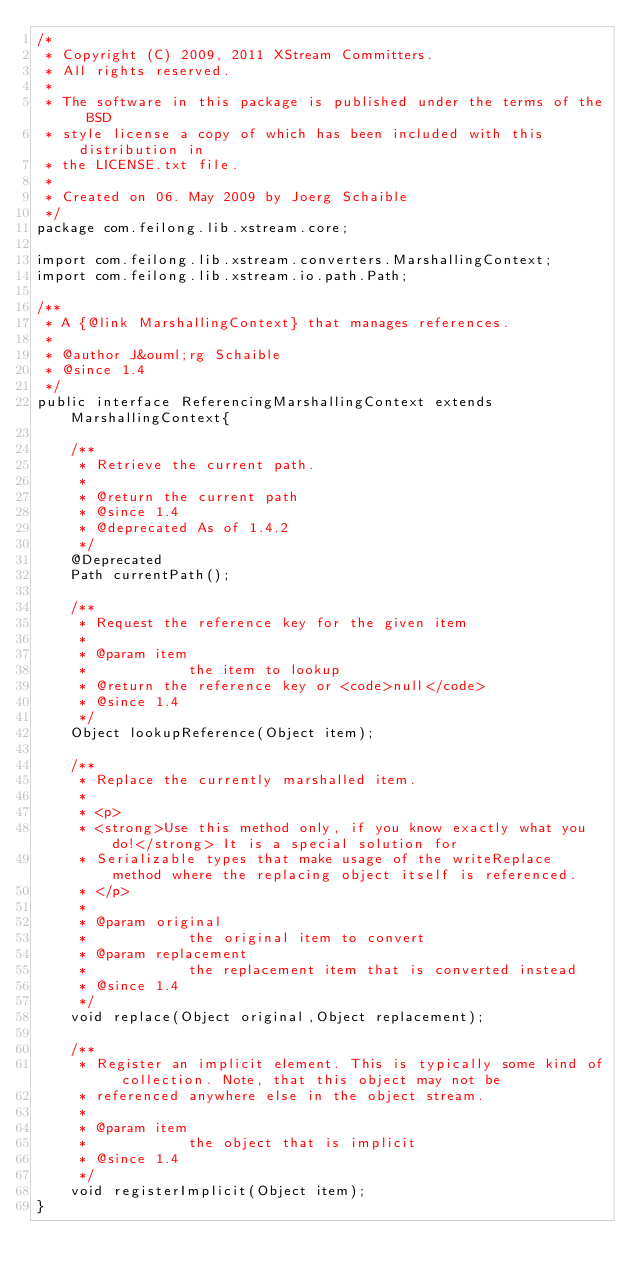Convert code to text. <code><loc_0><loc_0><loc_500><loc_500><_Java_>/*
 * Copyright (C) 2009, 2011 XStream Committers.
 * All rights reserved.
 *
 * The software in this package is published under the terms of the BSD
 * style license a copy of which has been included with this distribution in
 * the LICENSE.txt file.
 *
 * Created on 06. May 2009 by Joerg Schaible
 */
package com.feilong.lib.xstream.core;

import com.feilong.lib.xstream.converters.MarshallingContext;
import com.feilong.lib.xstream.io.path.Path;

/**
 * A {@link MarshallingContext} that manages references.
 * 
 * @author J&ouml;rg Schaible
 * @since 1.4
 */
public interface ReferencingMarshallingContext extends MarshallingContext{

    /**
     * Retrieve the current path.
     * 
     * @return the current path
     * @since 1.4
     * @deprecated As of 1.4.2
     */
    @Deprecated
    Path currentPath();

    /**
     * Request the reference key for the given item
     * 
     * @param item
     *            the item to lookup
     * @return the reference key or <code>null</code>
     * @since 1.4
     */
    Object lookupReference(Object item);

    /**
     * Replace the currently marshalled item.
     * 
     * <p>
     * <strong>Use this method only, if you know exactly what you do!</strong> It is a special solution for
     * Serializable types that make usage of the writeReplace method where the replacing object itself is referenced.
     * </p>
     * 
     * @param original
     *            the original item to convert
     * @param replacement
     *            the replacement item that is converted instead
     * @since 1.4
     */
    void replace(Object original,Object replacement);

    /**
     * Register an implicit element. This is typically some kind of collection. Note, that this object may not be
     * referenced anywhere else in the object stream.
     * 
     * @param item
     *            the object that is implicit
     * @since 1.4
     */
    void registerImplicit(Object item);
}
</code> 